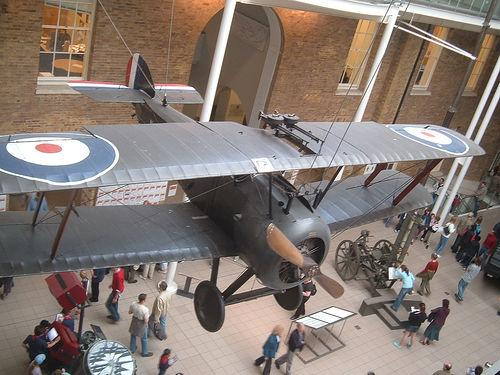What does this building house?

Choices:
A) candy shop
B) airport
C) museum
D) train depot museum 